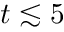<formula> <loc_0><loc_0><loc_500><loc_500>t \lesssim 5</formula> 